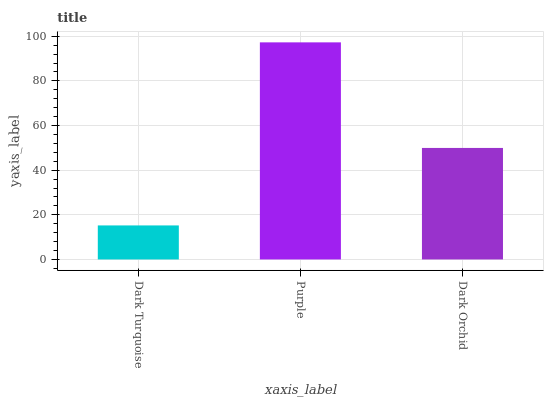Is Dark Turquoise the minimum?
Answer yes or no. Yes. Is Purple the maximum?
Answer yes or no. Yes. Is Dark Orchid the minimum?
Answer yes or no. No. Is Dark Orchid the maximum?
Answer yes or no. No. Is Purple greater than Dark Orchid?
Answer yes or no. Yes. Is Dark Orchid less than Purple?
Answer yes or no. Yes. Is Dark Orchid greater than Purple?
Answer yes or no. No. Is Purple less than Dark Orchid?
Answer yes or no. No. Is Dark Orchid the high median?
Answer yes or no. Yes. Is Dark Orchid the low median?
Answer yes or no. Yes. Is Purple the high median?
Answer yes or no. No. Is Purple the low median?
Answer yes or no. No. 